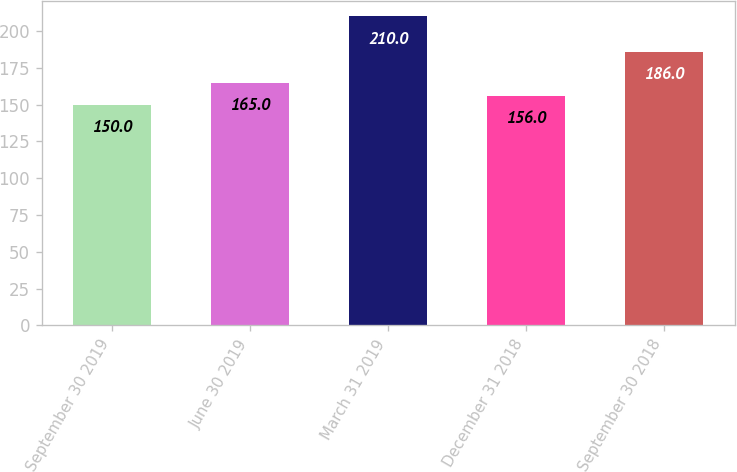Convert chart. <chart><loc_0><loc_0><loc_500><loc_500><bar_chart><fcel>September 30 2019<fcel>June 30 2019<fcel>March 31 2019<fcel>December 31 2018<fcel>September 30 2018<nl><fcel>150<fcel>165<fcel>210<fcel>156<fcel>186<nl></chart> 